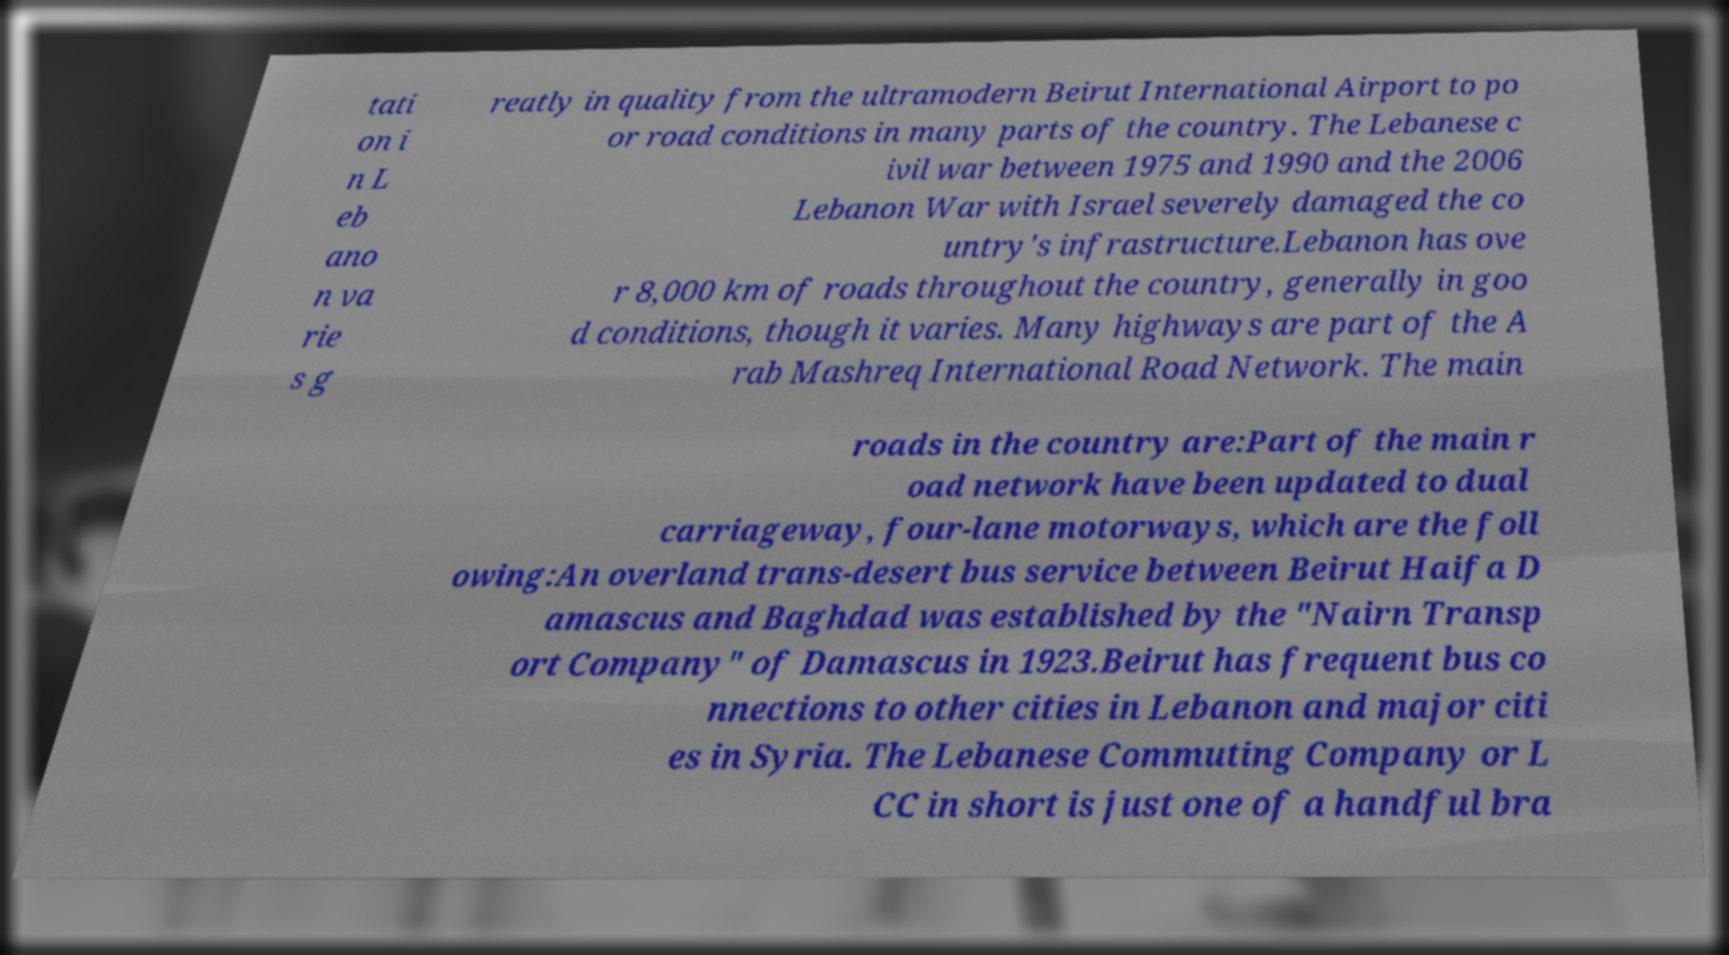Could you assist in decoding the text presented in this image and type it out clearly? tati on i n L eb ano n va rie s g reatly in quality from the ultramodern Beirut International Airport to po or road conditions in many parts of the country. The Lebanese c ivil war between 1975 and 1990 and the 2006 Lebanon War with Israel severely damaged the co untry's infrastructure.Lebanon has ove r 8,000 km of roads throughout the country, generally in goo d conditions, though it varies. Many highways are part of the A rab Mashreq International Road Network. The main roads in the country are:Part of the main r oad network have been updated to dual carriageway, four-lane motorways, which are the foll owing:An overland trans-desert bus service between Beirut Haifa D amascus and Baghdad was established by the "Nairn Transp ort Company" of Damascus in 1923.Beirut has frequent bus co nnections to other cities in Lebanon and major citi es in Syria. The Lebanese Commuting Company or L CC in short is just one of a handful bra 